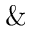<formula> <loc_0><loc_0><loc_500><loc_500>\&</formula> 